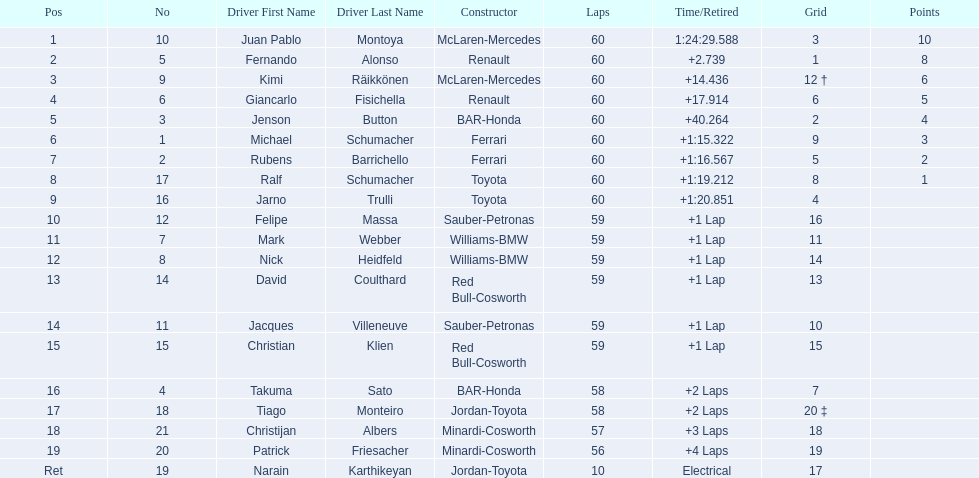Is there a points difference between the 9th position and 19th position on the list? No. 